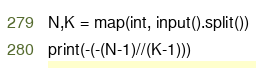Convert code to text. <code><loc_0><loc_0><loc_500><loc_500><_Python_>N,K = map(int, input().split())
print(-(-(N-1)//(K-1)))</code> 